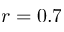<formula> <loc_0><loc_0><loc_500><loc_500>r = 0 . 7</formula> 